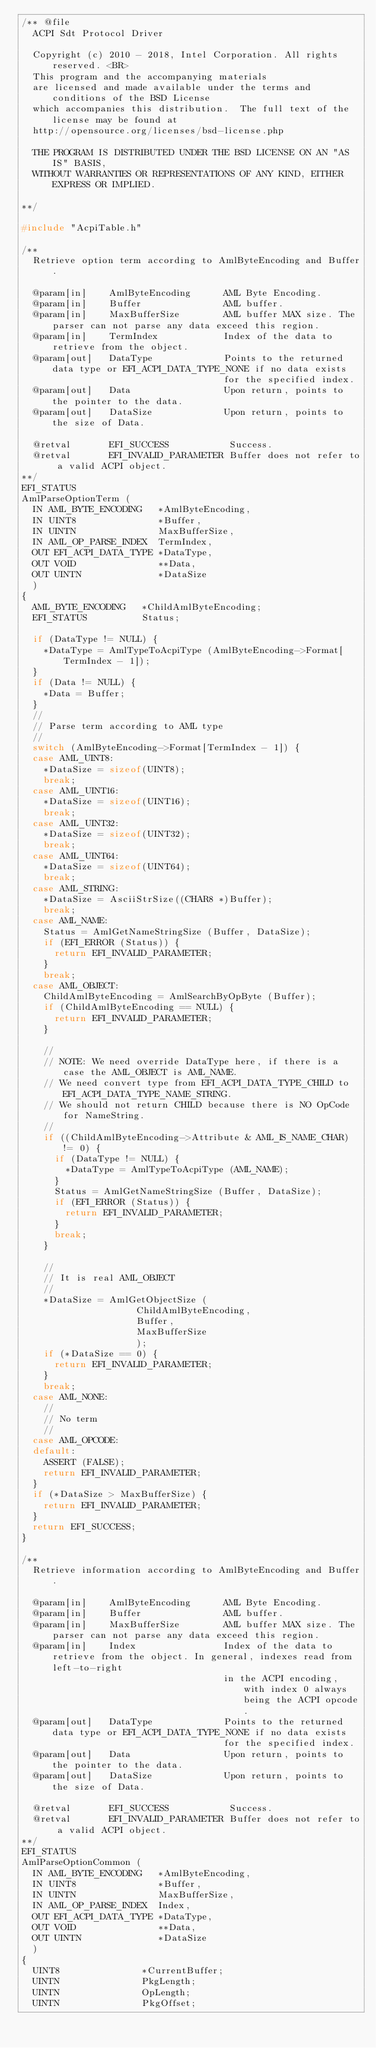Convert code to text. <code><loc_0><loc_0><loc_500><loc_500><_C_>/** @file
  ACPI Sdt Protocol Driver

  Copyright (c) 2010 - 2018, Intel Corporation. All rights reserved. <BR>
  This program and the accompanying materials
  are licensed and made available under the terms and conditions of the BSD License
  which accompanies this distribution.  The full text of the license may be found at
  http://opensource.org/licenses/bsd-license.php

  THE PROGRAM IS DISTRIBUTED UNDER THE BSD LICENSE ON AN "AS IS" BASIS,
  WITHOUT WARRANTIES OR REPRESENTATIONS OF ANY KIND, EITHER EXPRESS OR IMPLIED.

**/

#include "AcpiTable.h"

/**
  Retrieve option term according to AmlByteEncoding and Buffer.

  @param[in]    AmlByteEncoding      AML Byte Encoding.
  @param[in]    Buffer               AML buffer.
  @param[in]    MaxBufferSize        AML buffer MAX size. The parser can not parse any data exceed this region.
  @param[in]    TermIndex            Index of the data to retrieve from the object.
  @param[out]   DataType             Points to the returned data type or EFI_ACPI_DATA_TYPE_NONE if no data exists
                                     for the specified index.
  @param[out]   Data                 Upon return, points to the pointer to the data.
  @param[out]   DataSize             Upon return, points to the size of Data.

  @retval       EFI_SUCCESS           Success.
  @retval       EFI_INVALID_PARAMETER Buffer does not refer to a valid ACPI object.
**/
EFI_STATUS
AmlParseOptionTerm (
  IN AML_BYTE_ENCODING   *AmlByteEncoding,
  IN UINT8               *Buffer,
  IN UINTN               MaxBufferSize,
  IN AML_OP_PARSE_INDEX  TermIndex,
  OUT EFI_ACPI_DATA_TYPE *DataType,
  OUT VOID               **Data,
  OUT UINTN              *DataSize
  )
{
  AML_BYTE_ENCODING   *ChildAmlByteEncoding;
  EFI_STATUS          Status;

  if (DataType != NULL) {
    *DataType = AmlTypeToAcpiType (AmlByteEncoding->Format[TermIndex - 1]);
  }
  if (Data != NULL) {
    *Data = Buffer;
  }
  //
  // Parse term according to AML type
  //
  switch (AmlByteEncoding->Format[TermIndex - 1]) {
  case AML_UINT8:
    *DataSize = sizeof(UINT8);
    break;
  case AML_UINT16:
    *DataSize = sizeof(UINT16);
    break;
  case AML_UINT32:
    *DataSize = sizeof(UINT32);
    break;
  case AML_UINT64:
    *DataSize = sizeof(UINT64);
    break;
  case AML_STRING:
    *DataSize = AsciiStrSize((CHAR8 *)Buffer);
    break;
  case AML_NAME:
    Status = AmlGetNameStringSize (Buffer, DataSize);
    if (EFI_ERROR (Status)) {
      return EFI_INVALID_PARAMETER;
    }
    break;
  case AML_OBJECT:
    ChildAmlByteEncoding = AmlSearchByOpByte (Buffer);
    if (ChildAmlByteEncoding == NULL) {
      return EFI_INVALID_PARAMETER;
    }

    //
    // NOTE: We need override DataType here, if there is a case the AML_OBJECT is AML_NAME.
    // We need convert type from EFI_ACPI_DATA_TYPE_CHILD to EFI_ACPI_DATA_TYPE_NAME_STRING.
    // We should not return CHILD because there is NO OpCode for NameString.
    //
    if ((ChildAmlByteEncoding->Attribute & AML_IS_NAME_CHAR) != 0) {
      if (DataType != NULL) {
        *DataType = AmlTypeToAcpiType (AML_NAME);
      }
      Status = AmlGetNameStringSize (Buffer, DataSize);
      if (EFI_ERROR (Status)) {
        return EFI_INVALID_PARAMETER;
      }
      break;
    }

    //
    // It is real AML_OBJECT
    //
    *DataSize = AmlGetObjectSize (
                     ChildAmlByteEncoding,
                     Buffer,
                     MaxBufferSize
                     );
    if (*DataSize == 0) {
      return EFI_INVALID_PARAMETER;
    }
    break;
  case AML_NONE:
    //
    // No term
    //
  case AML_OPCODE:
  default:
    ASSERT (FALSE);
    return EFI_INVALID_PARAMETER;
  }
  if (*DataSize > MaxBufferSize) {
    return EFI_INVALID_PARAMETER;
  }
  return EFI_SUCCESS;
}

/**
  Retrieve information according to AmlByteEncoding and Buffer.

  @param[in]    AmlByteEncoding      AML Byte Encoding.
  @param[in]    Buffer               AML buffer.
  @param[in]    MaxBufferSize        AML buffer MAX size. The parser can not parse any data exceed this region.
  @param[in]    Index                Index of the data to retrieve from the object. In general, indexes read from left-to-right
                                     in the ACPI encoding, with index 0 always being the ACPI opcode.
  @param[out]   DataType             Points to the returned data type or EFI_ACPI_DATA_TYPE_NONE if no data exists
                                     for the specified index.
  @param[out]   Data                 Upon return, points to the pointer to the data.
  @param[out]   DataSize             Upon return, points to the size of Data.

  @retval       EFI_SUCCESS           Success.
  @retval       EFI_INVALID_PARAMETER Buffer does not refer to a valid ACPI object.
**/
EFI_STATUS
AmlParseOptionCommon (
  IN AML_BYTE_ENCODING   *AmlByteEncoding,
  IN UINT8               *Buffer,
  IN UINTN               MaxBufferSize,
  IN AML_OP_PARSE_INDEX  Index,
  OUT EFI_ACPI_DATA_TYPE *DataType,
  OUT VOID               **Data,
  OUT UINTN              *DataSize
  )
{
  UINT8               *CurrentBuffer;
  UINTN               PkgLength;
  UINTN               OpLength;
  UINTN               PkgOffset;</code> 